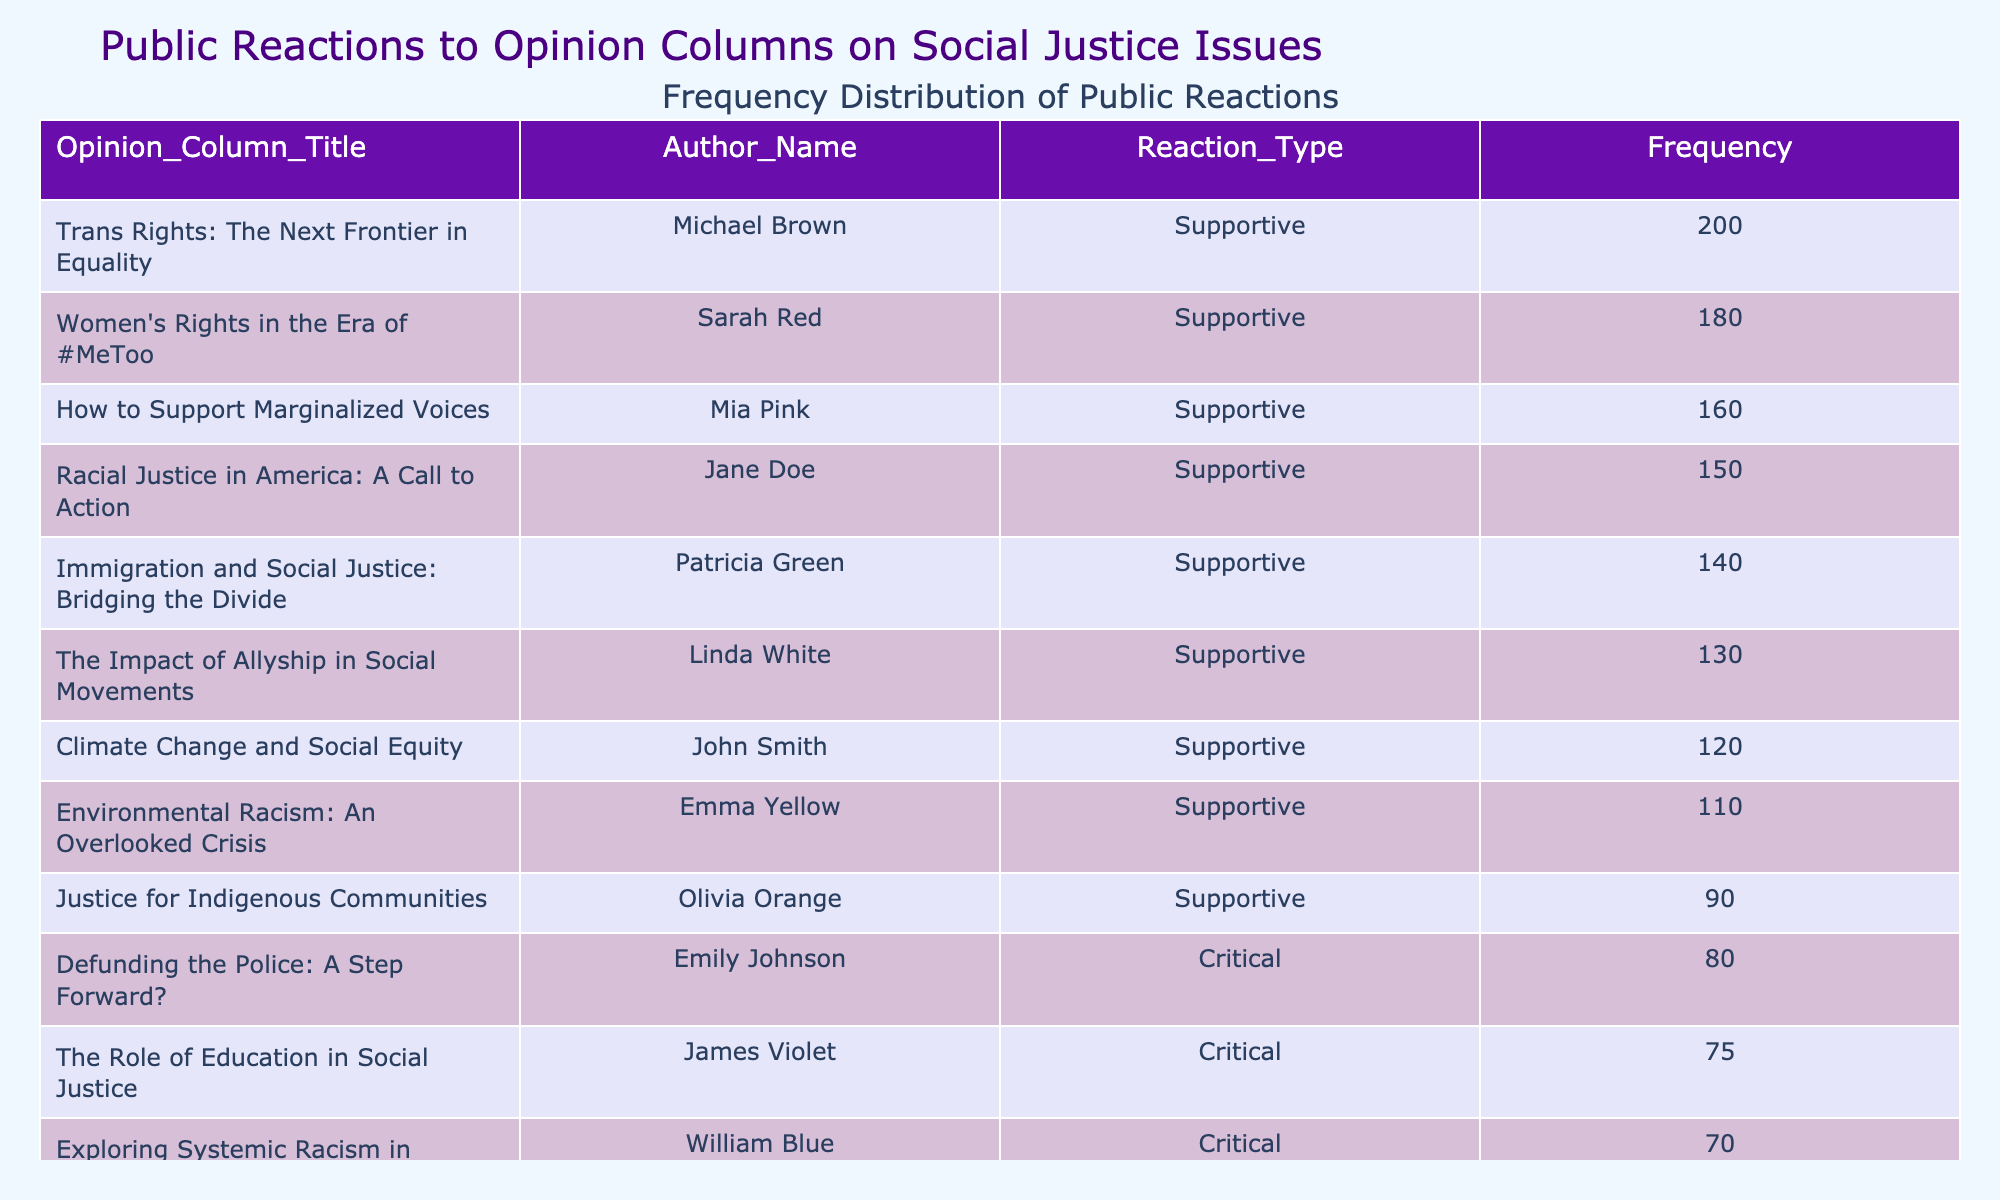What is the frequency of supportive reactions for the opinion column titled "Trans Rights: The Next Frontier in Equality"? From the table, we can find the row corresponding to the opinion column "Trans Rights: The Next Frontier in Equality." In that row, the Frequency value listed is 200, indicating that there were 200 supportive reactions.
Answer: 200 Which opinion column received the highest number of critical reactions? To determine which opinion column received the highest critical reactions, we need to look for the frequencies under the "Critical" reaction type. The table shows "Defunding the Police: A Step Forward?" with 80 reactions and "Exploring Systemic Racism in Healthcare" with 70 reactions; thus, "Defunding the Police: A Step Forward?" has the highest at 80.
Answer: "Defunding the Police: A Step Forward?" What is the total frequency of supportive reactions across all opinion columns? To obtain the total frequency of supportive reactions, we should add up all the Frequency values where Reaction_Type is "Supportive." Adding 150 (Racial Justice), 120 (Climate Change), 200 (Trans Rights), 130 (Allyship), 180 (Women’s Rights), 140 (Immigration), 110 (Environmental Racism), and 160 (Support Marginalized) gives us 1,090.
Answer: 1090 Is there any opinion column that has received zero neutral reactions? We check the Reaction_Type columns labelled "Neutral" and see that the highest frequency is 60 for "Universal Basic Income," while there is another option with 40 for "Social Media's Influence." Since both have values, there are no opinion columns with zero neutral reactions.
Answer: Yes Which author has the highest total frequency of reactions for their columns? To find the author with the highest total frequency of reactions, we need to sum the frequencies for each author across all their respective columns. For example, Jane Doe has 150, John Smith has 120, Emily Johnson has 80, and others as well. Totaling these, Michael Brown (with 200) continues with other sums until concluding with Mia Pink (for 160). The highest total is for Michael Brown, who has 200.
Answer: Michael Brown 